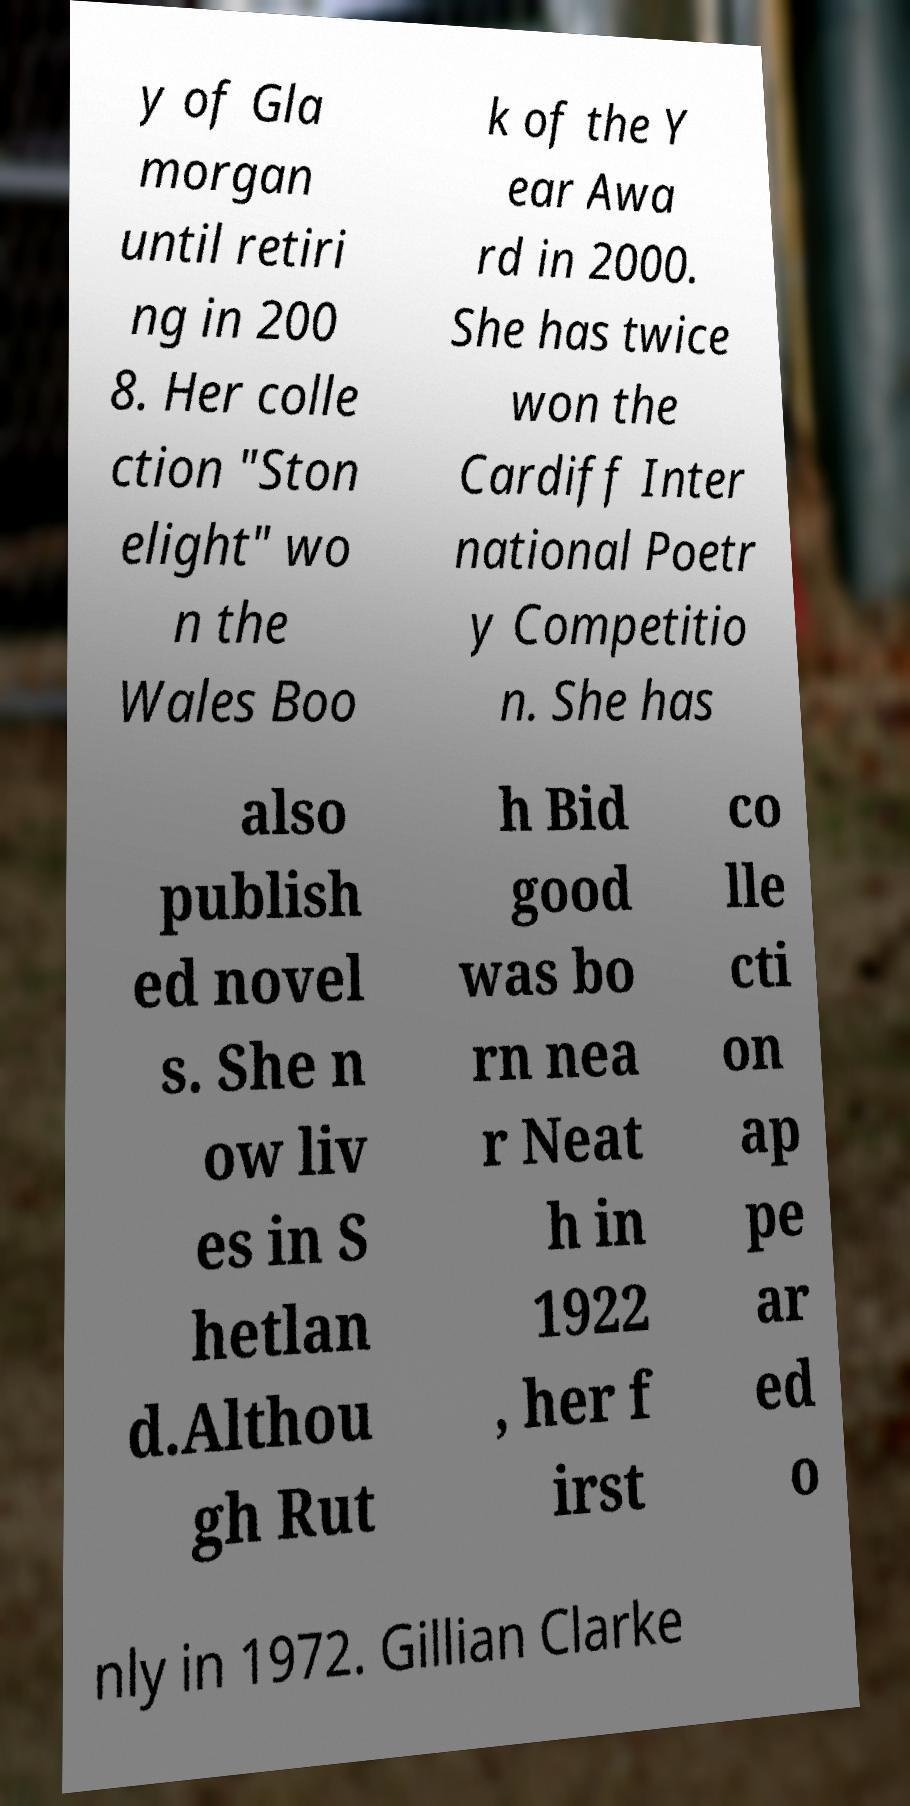For documentation purposes, I need the text within this image transcribed. Could you provide that? y of Gla morgan until retiri ng in 200 8. Her colle ction "Ston elight" wo n the Wales Boo k of the Y ear Awa rd in 2000. She has twice won the Cardiff Inter national Poetr y Competitio n. She has also publish ed novel s. She n ow liv es in S hetlan d.Althou gh Rut h Bid good was bo rn nea r Neat h in 1922 , her f irst co lle cti on ap pe ar ed o nly in 1972. Gillian Clarke 